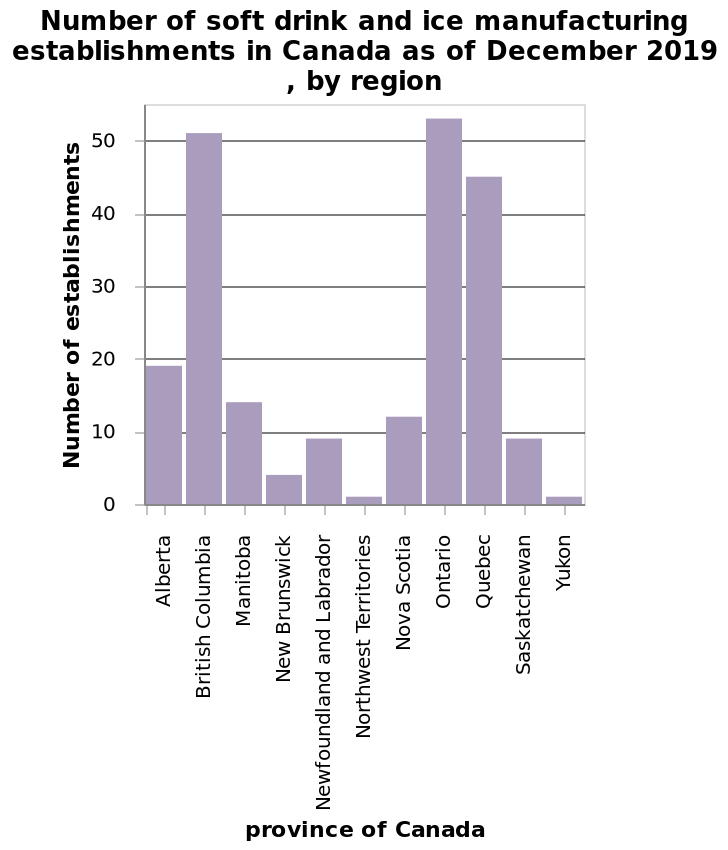<image>
How do the number of establishments differ between the built-up parts and smaller regions in Canada?  The built-up parts of Canada have more establishments compared to the smaller, less populated regions. Offer a thorough analysis of the image. there are more establishments in the built up parts of canada compared to the smaller less populated regions. Where are there more establishments in Canada, in the built-up parts or smaller regions?  There are more establishments in the built-up parts of Canada compared to the smaller, less populated regions. 